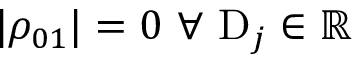<formula> <loc_0><loc_0><loc_500><loc_500>| \rho _ { 0 1 } | = 0 \ \forall \ D _ { j } \in \mathbb { R }</formula> 